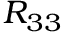Convert formula to latex. <formula><loc_0><loc_0><loc_500><loc_500>R _ { 3 3 }</formula> 